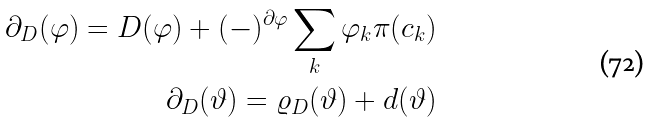Convert formula to latex. <formula><loc_0><loc_0><loc_500><loc_500>\partial _ { D } ( \varphi ) = D ( \varphi ) + ( - ) ^ { \partial \varphi } \sum _ { k } \varphi _ { k } \pi ( c _ { k } ) \\ \partial _ { D } ( \vartheta ) = \varrho _ { D } ( \vartheta ) + d ( \vartheta )</formula> 